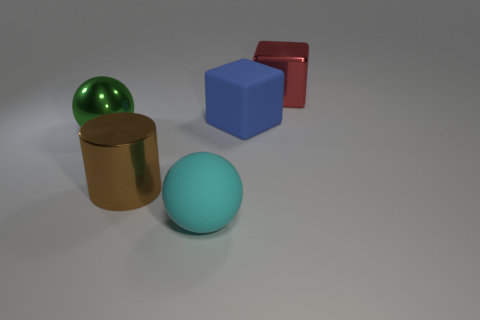The large sphere that is made of the same material as the red thing is what color? green 